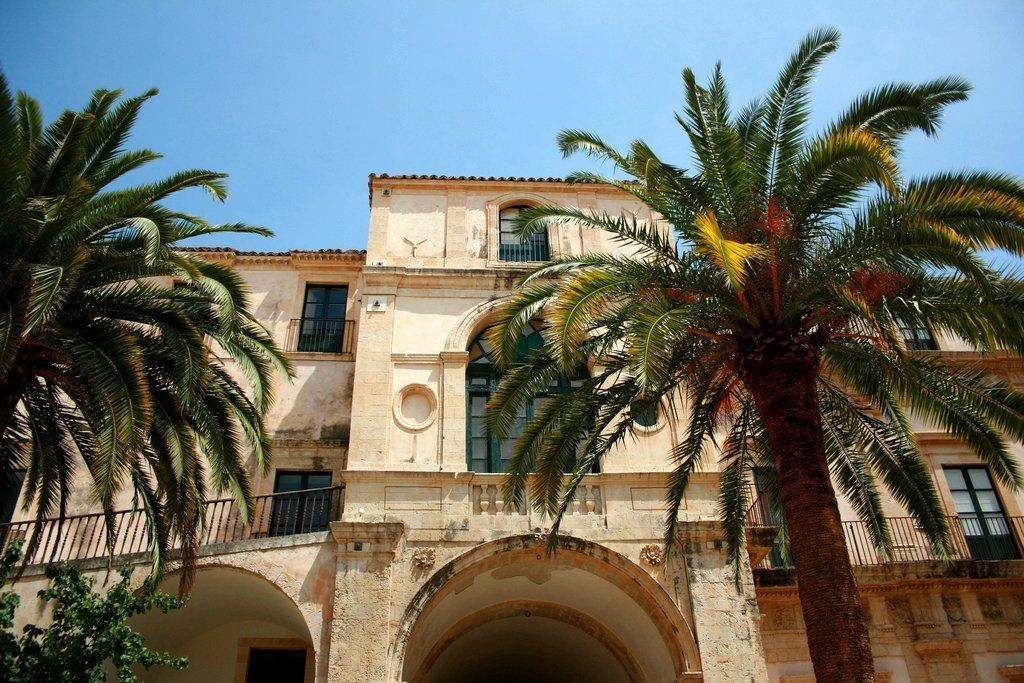What is the main structure in the picture? There is a building in the picture. What type of windows does the building have? The building has glass windows. What can be seen on both sides of the building? There are trees on either side of the building. What type of instrument is being played by the government in the image? There is no instrument or government present in the image; it only features a building with trees on either side. 